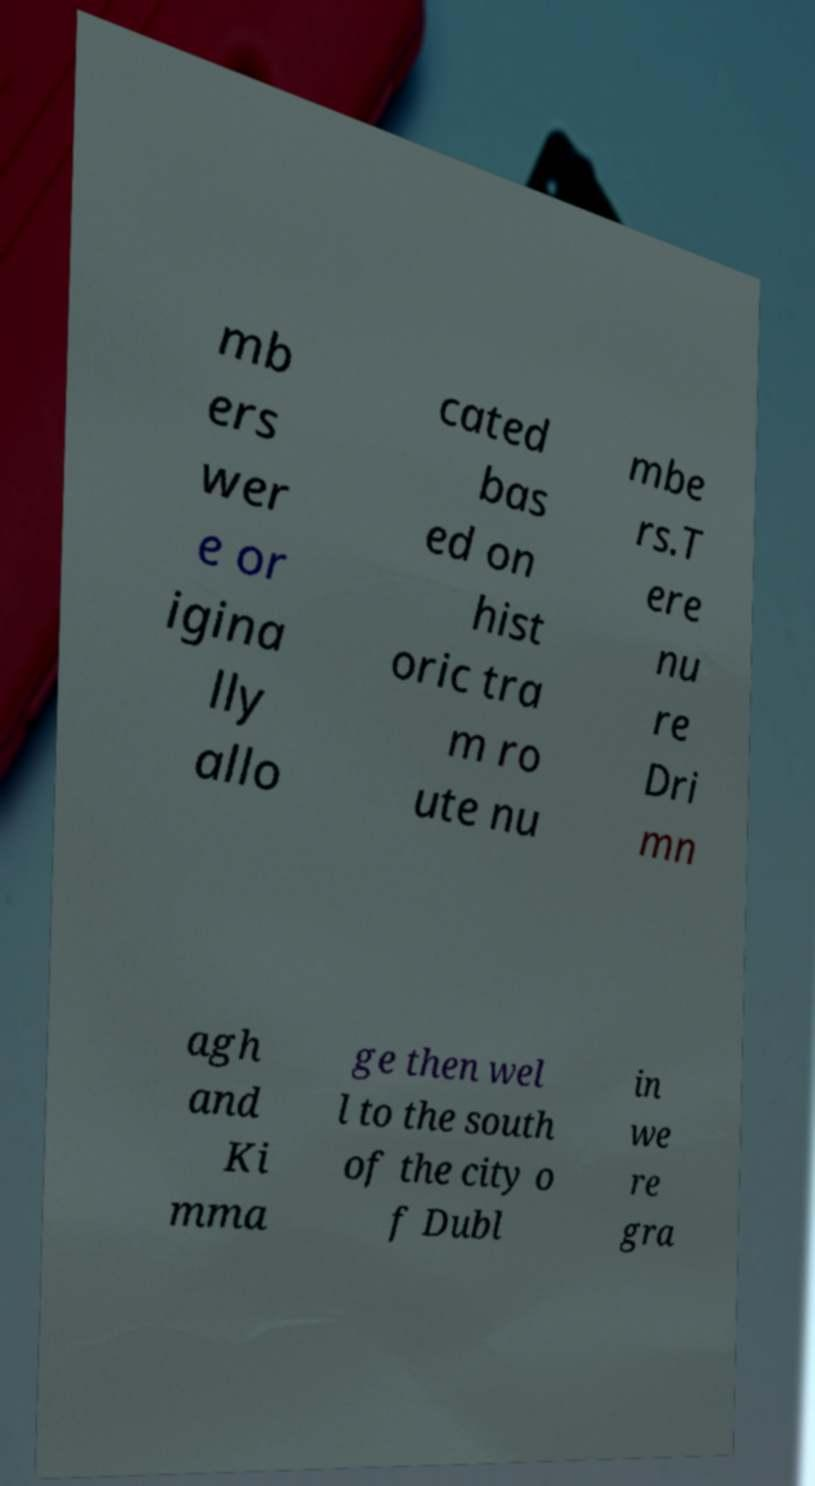There's text embedded in this image that I need extracted. Can you transcribe it verbatim? mb ers wer e or igina lly allo cated bas ed on hist oric tra m ro ute nu mbe rs.T ere nu re Dri mn agh and Ki mma ge then wel l to the south of the city o f Dubl in we re gra 